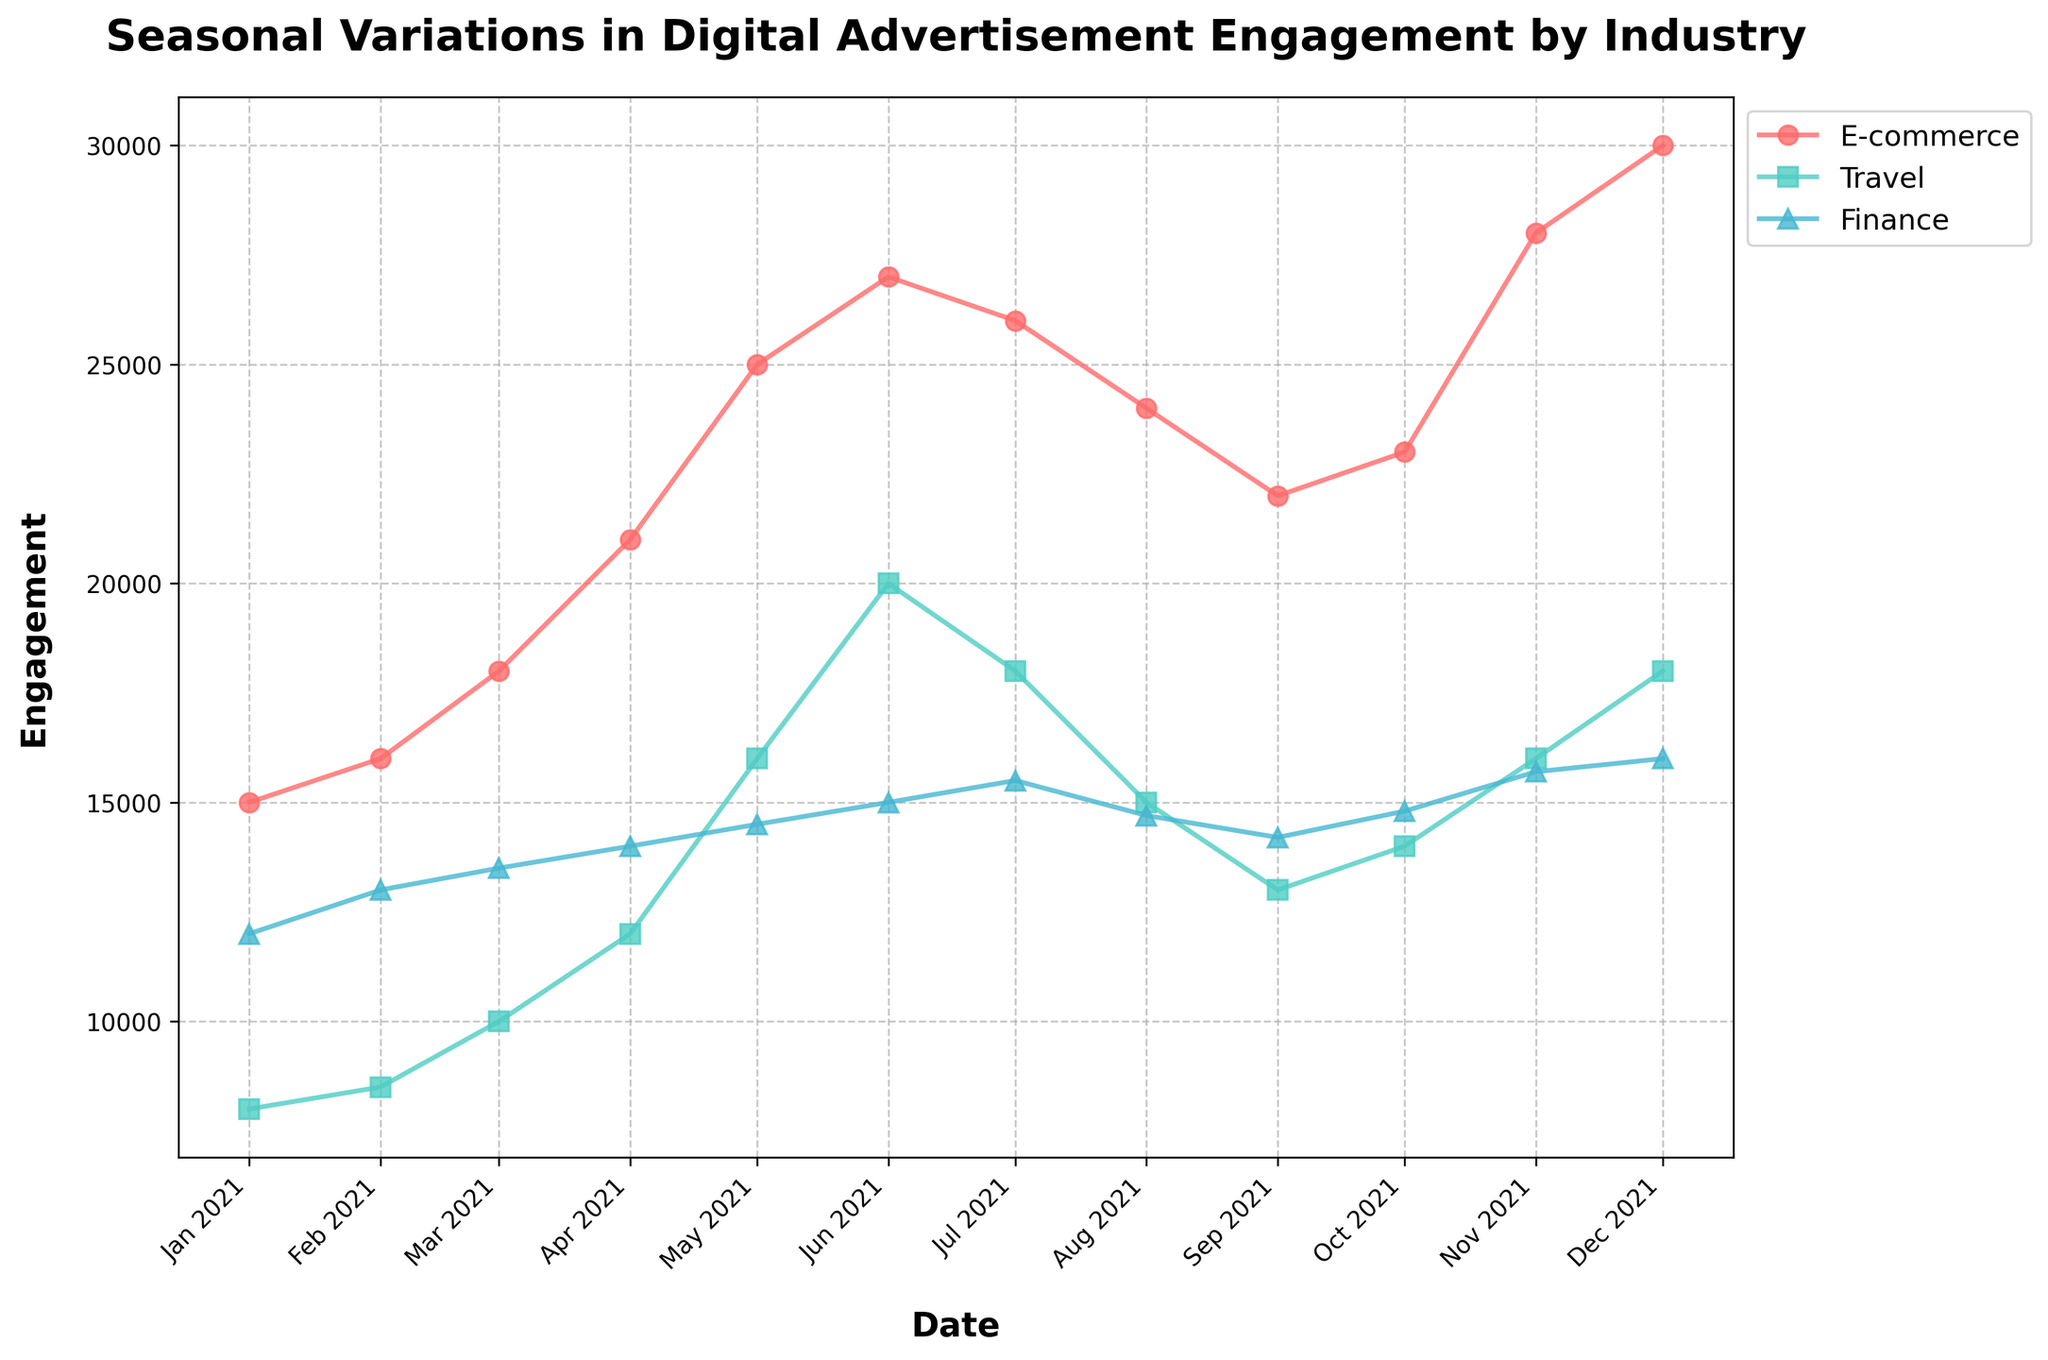What is the title of the plot? The title is usually found at the top of the plot in larger font, explicitly indicating the subject of the figure. In this case, it is "Seasonal Variations in Digital Advertisement Engagement by Industry."
Answer: Seasonal Variations in Digital Advertisement Engagement by Industry Which industry had the highest engagement in December 2021? To find the industry with the highest engagement, look at the data points corresponding to December 2021 on the x-axis and compare the engagement levels for each industry. The E-commerce line reaches the highest point in December 2021.
Answer: E-commerce Which month shows the peak value for the Travel industry, and what is that value? Track the Travel industry line (possibly with a square marker) through the entire plot to identify its highest point, which occurs in June 2021 with an engagement of 20,000.
Answer: June 2021, 20000 Describe the general trend of engagement for the Finance industry throughout the year 2021. To identify the trend, observe how the Finance industry's line changes from January 2021 to December 2021. The engagement gradually increases from January to December, with minor fluctuations.
Answer: Gradually increasing with minor fluctuations How does the engagement in May 2021 for the E-commerce industry compare to the Finance industry? To compare engagements for May 2021, look at both E-commerce and Finance data points for the month. E-commerce has 25,000 engagements while Finance has 14,500, so E-commerce has significantly higher engagement.
Answer: E-commerce is higher What is the average engagement from January to March 2021 for the Travel industry? Calculate the average by summing the monthly engagements from January to March for the Travel industry and dividing by the number of months: (8000 + 8500 + 10000) / 3 = 8,833.33.
Answer: 8,833.33 Which months did the E-commerce industry see a decline in engagement relative to the previous month in 2021? Look at the E-commerce line and identify where the points decrease compared to the previous month. There are declines in August 2021 (from July) and September 2021 (from August).
Answer: August and September What is the difference in engagement between the lowest and highest months for the Finance industry in 2021? Identify the highest and lowest points for the Finance industry line. The highest is December (16,000) and the lowest is January (12,000). The difference is 4000.
Answer: 4000 During which months do the Finance and Travel industries have equal engagement levels in 2021? Compare the Finance and Travel lines month-by-month to find any overlapping points. Both industries have an engagement of 14,000 in October 2021.
Answer: October What industries show a peak engagement in June 2021, and what are the respective values? Check the June 2021 data points for all three industries. Travel peaks at 20,000 and E-commerce peaks at 27,000 while Finance does not peak.
Answer: Travel (20,000), E-commerce (27,000) 